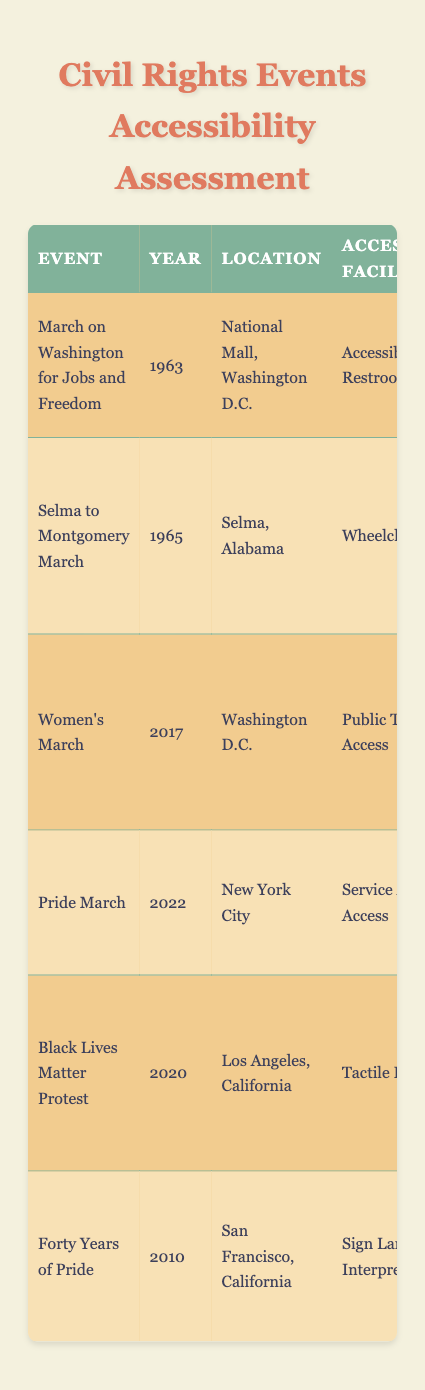What is the accessibility facility assessed for the Women's March? The table states that the Women's March had an accessibility facility of "Public Transport Access."
Answer: Public Transport Access Which event took place in New York City? Reviewing the table, the event listed in New York City is the "Pride March," which occurred in 2022.
Answer: Pride March What was the lowest assessment score in the table? The scores for the assessed events are 85, 70, 90, 95, 75, and 80. The lowest of these is 70, associated with the Selma to Montgomery March in 1965.
Answer: 70 How many events received an assessment score above 80? The scores above 80 are for the Women's March (90), Pride March (95), and the March on Washington for Jobs and Freedom (85). In total, there are three events that received scores above 80.
Answer: 3 Is there an event where service animal access was noted? Yes, the Pride March in 2022 specifically noted "Service Animal Access" in the accessibility facility.
Answer: Yes What event had major improvements made for ADA compliance after 1990, and what was its assessment score? The event "March on Washington for Jobs and Freedom" had major improvements for ADA compliance after 1990, and its assessment score is 85.
Answer: March on Washington for Jobs and Freedom, 85 Which event had the highest assessment score, and what accessibility facility was it associated with? The Pride March had the highest assessment score of 95, with the associated accessibility facility being "Service Animal Access."
Answer: Pride March, Service Animal Access What is the average assessment score of all the events listed? To find the average, sum the scores: 85 + 70 + 90 + 95 + 75 + 80 = 495. There are six events, so the average is 495 / 6 = 82.5.
Answer: 82.5 